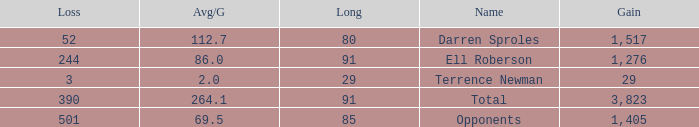When the Gain is 29, and the average per game is 2, and the player lost less than 390 yards, what's the sum of the Long yards? None. 